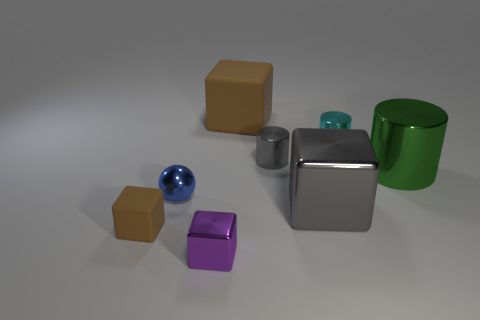Subtract all brown cubes. How many were subtracted if there are1brown cubes left? 1 Subtract all cyan metallic cylinders. How many cylinders are left? 2 Add 1 blue metal things. How many objects exist? 9 Subtract all spheres. How many objects are left? 7 Subtract 1 cubes. How many cubes are left? 3 Subtract all purple blocks. How many blocks are left? 3 Subtract all red blocks. Subtract all green cylinders. How many blocks are left? 4 Subtract all green cylinders. How many brown cubes are left? 2 Subtract all small gray balls. Subtract all big green metal objects. How many objects are left? 7 Add 3 tiny matte blocks. How many tiny matte blocks are left? 4 